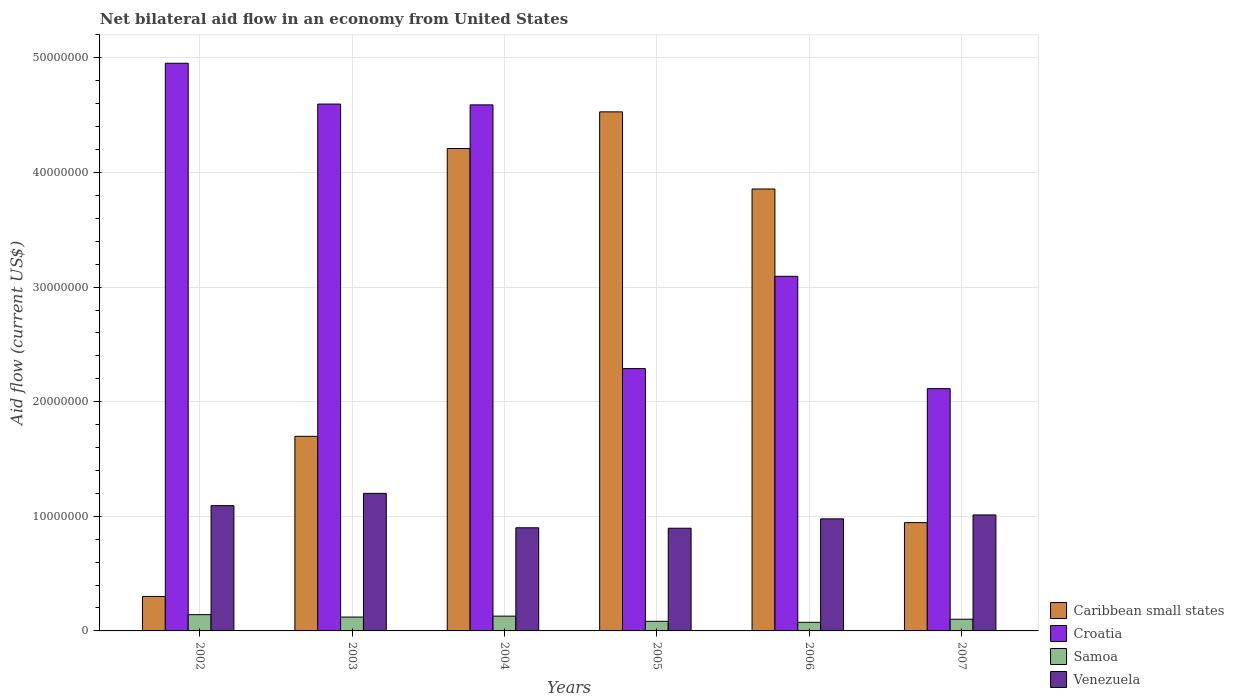How many bars are there on the 4th tick from the right?
Give a very brief answer. 4. What is the label of the 1st group of bars from the left?
Ensure brevity in your answer.  2002. What is the net bilateral aid flow in Venezuela in 2004?
Keep it short and to the point. 9.00e+06. Across all years, what is the maximum net bilateral aid flow in Samoa?
Offer a terse response. 1.42e+06. Across all years, what is the minimum net bilateral aid flow in Samoa?
Provide a succinct answer. 7.50e+05. In which year was the net bilateral aid flow in Caribbean small states minimum?
Make the answer very short. 2002. What is the total net bilateral aid flow in Croatia in the graph?
Your response must be concise. 2.16e+08. What is the difference between the net bilateral aid flow in Caribbean small states in 2002 and that in 2005?
Your answer should be very brief. -4.23e+07. What is the difference between the net bilateral aid flow in Venezuela in 2003 and the net bilateral aid flow in Croatia in 2004?
Your response must be concise. -3.39e+07. What is the average net bilateral aid flow in Venezuela per year?
Offer a terse response. 1.01e+07. In the year 2002, what is the difference between the net bilateral aid flow in Caribbean small states and net bilateral aid flow in Venezuela?
Offer a very short reply. -7.92e+06. In how many years, is the net bilateral aid flow in Venezuela greater than 48000000 US$?
Offer a very short reply. 0. What is the ratio of the net bilateral aid flow in Croatia in 2002 to that in 2005?
Offer a terse response. 2.16. What is the difference between the highest and the lowest net bilateral aid flow in Venezuela?
Your answer should be compact. 3.04e+06. In how many years, is the net bilateral aid flow in Venezuela greater than the average net bilateral aid flow in Venezuela taken over all years?
Your response must be concise. 2. Is the sum of the net bilateral aid flow in Samoa in 2004 and 2006 greater than the maximum net bilateral aid flow in Caribbean small states across all years?
Your answer should be compact. No. What does the 4th bar from the left in 2002 represents?
Your answer should be compact. Venezuela. What does the 4th bar from the right in 2007 represents?
Ensure brevity in your answer.  Caribbean small states. How many bars are there?
Your answer should be very brief. 24. How many years are there in the graph?
Your answer should be compact. 6. What is the difference between two consecutive major ticks on the Y-axis?
Your answer should be very brief. 1.00e+07. Where does the legend appear in the graph?
Make the answer very short. Bottom right. How many legend labels are there?
Keep it short and to the point. 4. How are the legend labels stacked?
Give a very brief answer. Vertical. What is the title of the graph?
Keep it short and to the point. Net bilateral aid flow in an economy from United States. Does "Bahrain" appear as one of the legend labels in the graph?
Ensure brevity in your answer.  No. What is the label or title of the X-axis?
Your response must be concise. Years. What is the label or title of the Y-axis?
Give a very brief answer. Aid flow (current US$). What is the Aid flow (current US$) in Caribbean small states in 2002?
Provide a succinct answer. 3.01e+06. What is the Aid flow (current US$) of Croatia in 2002?
Your answer should be compact. 4.95e+07. What is the Aid flow (current US$) of Samoa in 2002?
Your response must be concise. 1.42e+06. What is the Aid flow (current US$) of Venezuela in 2002?
Your response must be concise. 1.09e+07. What is the Aid flow (current US$) in Caribbean small states in 2003?
Provide a short and direct response. 1.70e+07. What is the Aid flow (current US$) in Croatia in 2003?
Your response must be concise. 4.60e+07. What is the Aid flow (current US$) in Samoa in 2003?
Offer a very short reply. 1.21e+06. What is the Aid flow (current US$) of Caribbean small states in 2004?
Provide a short and direct response. 4.21e+07. What is the Aid flow (current US$) of Croatia in 2004?
Your answer should be compact. 4.59e+07. What is the Aid flow (current US$) of Samoa in 2004?
Provide a short and direct response. 1.29e+06. What is the Aid flow (current US$) in Venezuela in 2004?
Your answer should be compact. 9.00e+06. What is the Aid flow (current US$) in Caribbean small states in 2005?
Give a very brief answer. 4.53e+07. What is the Aid flow (current US$) of Croatia in 2005?
Keep it short and to the point. 2.29e+07. What is the Aid flow (current US$) of Samoa in 2005?
Your response must be concise. 8.40e+05. What is the Aid flow (current US$) of Venezuela in 2005?
Provide a succinct answer. 8.96e+06. What is the Aid flow (current US$) of Caribbean small states in 2006?
Your answer should be compact. 3.86e+07. What is the Aid flow (current US$) of Croatia in 2006?
Provide a succinct answer. 3.09e+07. What is the Aid flow (current US$) of Samoa in 2006?
Provide a succinct answer. 7.50e+05. What is the Aid flow (current US$) in Venezuela in 2006?
Your response must be concise. 9.78e+06. What is the Aid flow (current US$) in Caribbean small states in 2007?
Offer a terse response. 9.45e+06. What is the Aid flow (current US$) in Croatia in 2007?
Make the answer very short. 2.11e+07. What is the Aid flow (current US$) of Samoa in 2007?
Your response must be concise. 1.02e+06. What is the Aid flow (current US$) in Venezuela in 2007?
Ensure brevity in your answer.  1.01e+07. Across all years, what is the maximum Aid flow (current US$) of Caribbean small states?
Offer a terse response. 4.53e+07. Across all years, what is the maximum Aid flow (current US$) of Croatia?
Your answer should be very brief. 4.95e+07. Across all years, what is the maximum Aid flow (current US$) of Samoa?
Provide a succinct answer. 1.42e+06. Across all years, what is the maximum Aid flow (current US$) of Venezuela?
Provide a short and direct response. 1.20e+07. Across all years, what is the minimum Aid flow (current US$) in Caribbean small states?
Provide a short and direct response. 3.01e+06. Across all years, what is the minimum Aid flow (current US$) of Croatia?
Offer a terse response. 2.11e+07. Across all years, what is the minimum Aid flow (current US$) in Samoa?
Your answer should be very brief. 7.50e+05. Across all years, what is the minimum Aid flow (current US$) in Venezuela?
Your answer should be compact. 8.96e+06. What is the total Aid flow (current US$) of Caribbean small states in the graph?
Give a very brief answer. 1.55e+08. What is the total Aid flow (current US$) of Croatia in the graph?
Ensure brevity in your answer.  2.16e+08. What is the total Aid flow (current US$) in Samoa in the graph?
Provide a short and direct response. 6.53e+06. What is the total Aid flow (current US$) in Venezuela in the graph?
Offer a terse response. 6.08e+07. What is the difference between the Aid flow (current US$) of Caribbean small states in 2002 and that in 2003?
Keep it short and to the point. -1.40e+07. What is the difference between the Aid flow (current US$) in Croatia in 2002 and that in 2003?
Offer a terse response. 3.56e+06. What is the difference between the Aid flow (current US$) in Venezuela in 2002 and that in 2003?
Give a very brief answer. -1.07e+06. What is the difference between the Aid flow (current US$) of Caribbean small states in 2002 and that in 2004?
Your answer should be very brief. -3.91e+07. What is the difference between the Aid flow (current US$) in Croatia in 2002 and that in 2004?
Your response must be concise. 3.63e+06. What is the difference between the Aid flow (current US$) of Venezuela in 2002 and that in 2004?
Your answer should be very brief. 1.93e+06. What is the difference between the Aid flow (current US$) in Caribbean small states in 2002 and that in 2005?
Give a very brief answer. -4.23e+07. What is the difference between the Aid flow (current US$) of Croatia in 2002 and that in 2005?
Provide a succinct answer. 2.66e+07. What is the difference between the Aid flow (current US$) in Samoa in 2002 and that in 2005?
Make the answer very short. 5.80e+05. What is the difference between the Aid flow (current US$) in Venezuela in 2002 and that in 2005?
Provide a short and direct response. 1.97e+06. What is the difference between the Aid flow (current US$) in Caribbean small states in 2002 and that in 2006?
Keep it short and to the point. -3.56e+07. What is the difference between the Aid flow (current US$) in Croatia in 2002 and that in 2006?
Give a very brief answer. 1.86e+07. What is the difference between the Aid flow (current US$) in Samoa in 2002 and that in 2006?
Ensure brevity in your answer.  6.70e+05. What is the difference between the Aid flow (current US$) in Venezuela in 2002 and that in 2006?
Keep it short and to the point. 1.15e+06. What is the difference between the Aid flow (current US$) of Caribbean small states in 2002 and that in 2007?
Make the answer very short. -6.44e+06. What is the difference between the Aid flow (current US$) in Croatia in 2002 and that in 2007?
Make the answer very short. 2.84e+07. What is the difference between the Aid flow (current US$) in Venezuela in 2002 and that in 2007?
Keep it short and to the point. 8.10e+05. What is the difference between the Aid flow (current US$) of Caribbean small states in 2003 and that in 2004?
Offer a very short reply. -2.51e+07. What is the difference between the Aid flow (current US$) of Samoa in 2003 and that in 2004?
Offer a terse response. -8.00e+04. What is the difference between the Aid flow (current US$) of Caribbean small states in 2003 and that in 2005?
Keep it short and to the point. -2.83e+07. What is the difference between the Aid flow (current US$) of Croatia in 2003 and that in 2005?
Your answer should be very brief. 2.31e+07. What is the difference between the Aid flow (current US$) in Venezuela in 2003 and that in 2005?
Offer a very short reply. 3.04e+06. What is the difference between the Aid flow (current US$) in Caribbean small states in 2003 and that in 2006?
Your response must be concise. -2.16e+07. What is the difference between the Aid flow (current US$) of Croatia in 2003 and that in 2006?
Keep it short and to the point. 1.50e+07. What is the difference between the Aid flow (current US$) of Samoa in 2003 and that in 2006?
Keep it short and to the point. 4.60e+05. What is the difference between the Aid flow (current US$) in Venezuela in 2003 and that in 2006?
Offer a terse response. 2.22e+06. What is the difference between the Aid flow (current US$) of Caribbean small states in 2003 and that in 2007?
Provide a succinct answer. 7.53e+06. What is the difference between the Aid flow (current US$) in Croatia in 2003 and that in 2007?
Your answer should be compact. 2.48e+07. What is the difference between the Aid flow (current US$) in Venezuela in 2003 and that in 2007?
Keep it short and to the point. 1.88e+06. What is the difference between the Aid flow (current US$) of Caribbean small states in 2004 and that in 2005?
Make the answer very short. -3.20e+06. What is the difference between the Aid flow (current US$) of Croatia in 2004 and that in 2005?
Provide a short and direct response. 2.30e+07. What is the difference between the Aid flow (current US$) in Caribbean small states in 2004 and that in 2006?
Offer a very short reply. 3.53e+06. What is the difference between the Aid flow (current US$) of Croatia in 2004 and that in 2006?
Offer a terse response. 1.50e+07. What is the difference between the Aid flow (current US$) of Samoa in 2004 and that in 2006?
Provide a short and direct response. 5.40e+05. What is the difference between the Aid flow (current US$) of Venezuela in 2004 and that in 2006?
Provide a succinct answer. -7.80e+05. What is the difference between the Aid flow (current US$) of Caribbean small states in 2004 and that in 2007?
Offer a terse response. 3.26e+07. What is the difference between the Aid flow (current US$) in Croatia in 2004 and that in 2007?
Your answer should be very brief. 2.48e+07. What is the difference between the Aid flow (current US$) in Venezuela in 2004 and that in 2007?
Give a very brief answer. -1.12e+06. What is the difference between the Aid flow (current US$) in Caribbean small states in 2005 and that in 2006?
Give a very brief answer. 6.73e+06. What is the difference between the Aid flow (current US$) in Croatia in 2005 and that in 2006?
Ensure brevity in your answer.  -8.05e+06. What is the difference between the Aid flow (current US$) in Venezuela in 2005 and that in 2006?
Your answer should be compact. -8.20e+05. What is the difference between the Aid flow (current US$) in Caribbean small states in 2005 and that in 2007?
Offer a very short reply. 3.58e+07. What is the difference between the Aid flow (current US$) in Croatia in 2005 and that in 2007?
Provide a succinct answer. 1.75e+06. What is the difference between the Aid flow (current US$) in Samoa in 2005 and that in 2007?
Provide a short and direct response. -1.80e+05. What is the difference between the Aid flow (current US$) of Venezuela in 2005 and that in 2007?
Offer a very short reply. -1.16e+06. What is the difference between the Aid flow (current US$) in Caribbean small states in 2006 and that in 2007?
Offer a very short reply. 2.91e+07. What is the difference between the Aid flow (current US$) in Croatia in 2006 and that in 2007?
Provide a short and direct response. 9.80e+06. What is the difference between the Aid flow (current US$) of Venezuela in 2006 and that in 2007?
Your answer should be very brief. -3.40e+05. What is the difference between the Aid flow (current US$) of Caribbean small states in 2002 and the Aid flow (current US$) of Croatia in 2003?
Provide a succinct answer. -4.30e+07. What is the difference between the Aid flow (current US$) in Caribbean small states in 2002 and the Aid flow (current US$) in Samoa in 2003?
Give a very brief answer. 1.80e+06. What is the difference between the Aid flow (current US$) of Caribbean small states in 2002 and the Aid flow (current US$) of Venezuela in 2003?
Provide a succinct answer. -8.99e+06. What is the difference between the Aid flow (current US$) of Croatia in 2002 and the Aid flow (current US$) of Samoa in 2003?
Keep it short and to the point. 4.83e+07. What is the difference between the Aid flow (current US$) of Croatia in 2002 and the Aid flow (current US$) of Venezuela in 2003?
Your response must be concise. 3.75e+07. What is the difference between the Aid flow (current US$) of Samoa in 2002 and the Aid flow (current US$) of Venezuela in 2003?
Your answer should be compact. -1.06e+07. What is the difference between the Aid flow (current US$) of Caribbean small states in 2002 and the Aid flow (current US$) of Croatia in 2004?
Your response must be concise. -4.29e+07. What is the difference between the Aid flow (current US$) of Caribbean small states in 2002 and the Aid flow (current US$) of Samoa in 2004?
Offer a terse response. 1.72e+06. What is the difference between the Aid flow (current US$) of Caribbean small states in 2002 and the Aid flow (current US$) of Venezuela in 2004?
Your answer should be compact. -5.99e+06. What is the difference between the Aid flow (current US$) of Croatia in 2002 and the Aid flow (current US$) of Samoa in 2004?
Offer a terse response. 4.82e+07. What is the difference between the Aid flow (current US$) in Croatia in 2002 and the Aid flow (current US$) in Venezuela in 2004?
Offer a very short reply. 4.05e+07. What is the difference between the Aid flow (current US$) of Samoa in 2002 and the Aid flow (current US$) of Venezuela in 2004?
Provide a short and direct response. -7.58e+06. What is the difference between the Aid flow (current US$) in Caribbean small states in 2002 and the Aid flow (current US$) in Croatia in 2005?
Provide a succinct answer. -1.99e+07. What is the difference between the Aid flow (current US$) of Caribbean small states in 2002 and the Aid flow (current US$) of Samoa in 2005?
Ensure brevity in your answer.  2.17e+06. What is the difference between the Aid flow (current US$) of Caribbean small states in 2002 and the Aid flow (current US$) of Venezuela in 2005?
Your answer should be very brief. -5.95e+06. What is the difference between the Aid flow (current US$) in Croatia in 2002 and the Aid flow (current US$) in Samoa in 2005?
Provide a succinct answer. 4.87e+07. What is the difference between the Aid flow (current US$) of Croatia in 2002 and the Aid flow (current US$) of Venezuela in 2005?
Ensure brevity in your answer.  4.06e+07. What is the difference between the Aid flow (current US$) of Samoa in 2002 and the Aid flow (current US$) of Venezuela in 2005?
Offer a terse response. -7.54e+06. What is the difference between the Aid flow (current US$) of Caribbean small states in 2002 and the Aid flow (current US$) of Croatia in 2006?
Your response must be concise. -2.79e+07. What is the difference between the Aid flow (current US$) in Caribbean small states in 2002 and the Aid flow (current US$) in Samoa in 2006?
Ensure brevity in your answer.  2.26e+06. What is the difference between the Aid flow (current US$) of Caribbean small states in 2002 and the Aid flow (current US$) of Venezuela in 2006?
Ensure brevity in your answer.  -6.77e+06. What is the difference between the Aid flow (current US$) of Croatia in 2002 and the Aid flow (current US$) of Samoa in 2006?
Offer a terse response. 4.88e+07. What is the difference between the Aid flow (current US$) of Croatia in 2002 and the Aid flow (current US$) of Venezuela in 2006?
Give a very brief answer. 3.98e+07. What is the difference between the Aid flow (current US$) of Samoa in 2002 and the Aid flow (current US$) of Venezuela in 2006?
Your response must be concise. -8.36e+06. What is the difference between the Aid flow (current US$) of Caribbean small states in 2002 and the Aid flow (current US$) of Croatia in 2007?
Provide a short and direct response. -1.81e+07. What is the difference between the Aid flow (current US$) in Caribbean small states in 2002 and the Aid flow (current US$) in Samoa in 2007?
Provide a succinct answer. 1.99e+06. What is the difference between the Aid flow (current US$) in Caribbean small states in 2002 and the Aid flow (current US$) in Venezuela in 2007?
Offer a very short reply. -7.11e+06. What is the difference between the Aid flow (current US$) of Croatia in 2002 and the Aid flow (current US$) of Samoa in 2007?
Your answer should be very brief. 4.85e+07. What is the difference between the Aid flow (current US$) of Croatia in 2002 and the Aid flow (current US$) of Venezuela in 2007?
Offer a terse response. 3.94e+07. What is the difference between the Aid flow (current US$) in Samoa in 2002 and the Aid flow (current US$) in Venezuela in 2007?
Provide a short and direct response. -8.70e+06. What is the difference between the Aid flow (current US$) in Caribbean small states in 2003 and the Aid flow (current US$) in Croatia in 2004?
Your answer should be compact. -2.89e+07. What is the difference between the Aid flow (current US$) of Caribbean small states in 2003 and the Aid flow (current US$) of Samoa in 2004?
Ensure brevity in your answer.  1.57e+07. What is the difference between the Aid flow (current US$) in Caribbean small states in 2003 and the Aid flow (current US$) in Venezuela in 2004?
Your answer should be very brief. 7.98e+06. What is the difference between the Aid flow (current US$) in Croatia in 2003 and the Aid flow (current US$) in Samoa in 2004?
Provide a short and direct response. 4.47e+07. What is the difference between the Aid flow (current US$) in Croatia in 2003 and the Aid flow (current US$) in Venezuela in 2004?
Your response must be concise. 3.70e+07. What is the difference between the Aid flow (current US$) in Samoa in 2003 and the Aid flow (current US$) in Venezuela in 2004?
Offer a terse response. -7.79e+06. What is the difference between the Aid flow (current US$) in Caribbean small states in 2003 and the Aid flow (current US$) in Croatia in 2005?
Provide a succinct answer. -5.91e+06. What is the difference between the Aid flow (current US$) of Caribbean small states in 2003 and the Aid flow (current US$) of Samoa in 2005?
Your answer should be very brief. 1.61e+07. What is the difference between the Aid flow (current US$) in Caribbean small states in 2003 and the Aid flow (current US$) in Venezuela in 2005?
Ensure brevity in your answer.  8.02e+06. What is the difference between the Aid flow (current US$) of Croatia in 2003 and the Aid flow (current US$) of Samoa in 2005?
Your response must be concise. 4.51e+07. What is the difference between the Aid flow (current US$) of Croatia in 2003 and the Aid flow (current US$) of Venezuela in 2005?
Your response must be concise. 3.70e+07. What is the difference between the Aid flow (current US$) in Samoa in 2003 and the Aid flow (current US$) in Venezuela in 2005?
Provide a short and direct response. -7.75e+06. What is the difference between the Aid flow (current US$) in Caribbean small states in 2003 and the Aid flow (current US$) in Croatia in 2006?
Your answer should be compact. -1.40e+07. What is the difference between the Aid flow (current US$) of Caribbean small states in 2003 and the Aid flow (current US$) of Samoa in 2006?
Keep it short and to the point. 1.62e+07. What is the difference between the Aid flow (current US$) of Caribbean small states in 2003 and the Aid flow (current US$) of Venezuela in 2006?
Your answer should be very brief. 7.20e+06. What is the difference between the Aid flow (current US$) in Croatia in 2003 and the Aid flow (current US$) in Samoa in 2006?
Offer a terse response. 4.52e+07. What is the difference between the Aid flow (current US$) of Croatia in 2003 and the Aid flow (current US$) of Venezuela in 2006?
Your answer should be very brief. 3.62e+07. What is the difference between the Aid flow (current US$) in Samoa in 2003 and the Aid flow (current US$) in Venezuela in 2006?
Provide a succinct answer. -8.57e+06. What is the difference between the Aid flow (current US$) of Caribbean small states in 2003 and the Aid flow (current US$) of Croatia in 2007?
Your answer should be compact. -4.16e+06. What is the difference between the Aid flow (current US$) of Caribbean small states in 2003 and the Aid flow (current US$) of Samoa in 2007?
Provide a short and direct response. 1.60e+07. What is the difference between the Aid flow (current US$) of Caribbean small states in 2003 and the Aid flow (current US$) of Venezuela in 2007?
Offer a very short reply. 6.86e+06. What is the difference between the Aid flow (current US$) of Croatia in 2003 and the Aid flow (current US$) of Samoa in 2007?
Make the answer very short. 4.50e+07. What is the difference between the Aid flow (current US$) of Croatia in 2003 and the Aid flow (current US$) of Venezuela in 2007?
Keep it short and to the point. 3.58e+07. What is the difference between the Aid flow (current US$) of Samoa in 2003 and the Aid flow (current US$) of Venezuela in 2007?
Provide a succinct answer. -8.91e+06. What is the difference between the Aid flow (current US$) of Caribbean small states in 2004 and the Aid flow (current US$) of Croatia in 2005?
Your answer should be compact. 1.92e+07. What is the difference between the Aid flow (current US$) of Caribbean small states in 2004 and the Aid flow (current US$) of Samoa in 2005?
Keep it short and to the point. 4.12e+07. What is the difference between the Aid flow (current US$) of Caribbean small states in 2004 and the Aid flow (current US$) of Venezuela in 2005?
Offer a very short reply. 3.31e+07. What is the difference between the Aid flow (current US$) of Croatia in 2004 and the Aid flow (current US$) of Samoa in 2005?
Your answer should be compact. 4.51e+07. What is the difference between the Aid flow (current US$) of Croatia in 2004 and the Aid flow (current US$) of Venezuela in 2005?
Your answer should be compact. 3.69e+07. What is the difference between the Aid flow (current US$) in Samoa in 2004 and the Aid flow (current US$) in Venezuela in 2005?
Your answer should be very brief. -7.67e+06. What is the difference between the Aid flow (current US$) in Caribbean small states in 2004 and the Aid flow (current US$) in Croatia in 2006?
Provide a short and direct response. 1.12e+07. What is the difference between the Aid flow (current US$) in Caribbean small states in 2004 and the Aid flow (current US$) in Samoa in 2006?
Provide a succinct answer. 4.13e+07. What is the difference between the Aid flow (current US$) of Caribbean small states in 2004 and the Aid flow (current US$) of Venezuela in 2006?
Your answer should be very brief. 3.23e+07. What is the difference between the Aid flow (current US$) of Croatia in 2004 and the Aid flow (current US$) of Samoa in 2006?
Offer a very short reply. 4.52e+07. What is the difference between the Aid flow (current US$) in Croatia in 2004 and the Aid flow (current US$) in Venezuela in 2006?
Your answer should be compact. 3.61e+07. What is the difference between the Aid flow (current US$) in Samoa in 2004 and the Aid flow (current US$) in Venezuela in 2006?
Ensure brevity in your answer.  -8.49e+06. What is the difference between the Aid flow (current US$) in Caribbean small states in 2004 and the Aid flow (current US$) in Croatia in 2007?
Offer a terse response. 2.10e+07. What is the difference between the Aid flow (current US$) in Caribbean small states in 2004 and the Aid flow (current US$) in Samoa in 2007?
Ensure brevity in your answer.  4.11e+07. What is the difference between the Aid flow (current US$) in Caribbean small states in 2004 and the Aid flow (current US$) in Venezuela in 2007?
Provide a short and direct response. 3.20e+07. What is the difference between the Aid flow (current US$) of Croatia in 2004 and the Aid flow (current US$) of Samoa in 2007?
Keep it short and to the point. 4.49e+07. What is the difference between the Aid flow (current US$) of Croatia in 2004 and the Aid flow (current US$) of Venezuela in 2007?
Offer a terse response. 3.58e+07. What is the difference between the Aid flow (current US$) of Samoa in 2004 and the Aid flow (current US$) of Venezuela in 2007?
Your answer should be very brief. -8.83e+06. What is the difference between the Aid flow (current US$) in Caribbean small states in 2005 and the Aid flow (current US$) in Croatia in 2006?
Provide a short and direct response. 1.44e+07. What is the difference between the Aid flow (current US$) in Caribbean small states in 2005 and the Aid flow (current US$) in Samoa in 2006?
Provide a succinct answer. 4.45e+07. What is the difference between the Aid flow (current US$) of Caribbean small states in 2005 and the Aid flow (current US$) of Venezuela in 2006?
Give a very brief answer. 3.55e+07. What is the difference between the Aid flow (current US$) in Croatia in 2005 and the Aid flow (current US$) in Samoa in 2006?
Offer a terse response. 2.21e+07. What is the difference between the Aid flow (current US$) of Croatia in 2005 and the Aid flow (current US$) of Venezuela in 2006?
Provide a short and direct response. 1.31e+07. What is the difference between the Aid flow (current US$) in Samoa in 2005 and the Aid flow (current US$) in Venezuela in 2006?
Offer a terse response. -8.94e+06. What is the difference between the Aid flow (current US$) of Caribbean small states in 2005 and the Aid flow (current US$) of Croatia in 2007?
Provide a short and direct response. 2.42e+07. What is the difference between the Aid flow (current US$) of Caribbean small states in 2005 and the Aid flow (current US$) of Samoa in 2007?
Provide a succinct answer. 4.43e+07. What is the difference between the Aid flow (current US$) in Caribbean small states in 2005 and the Aid flow (current US$) in Venezuela in 2007?
Your answer should be compact. 3.52e+07. What is the difference between the Aid flow (current US$) of Croatia in 2005 and the Aid flow (current US$) of Samoa in 2007?
Keep it short and to the point. 2.19e+07. What is the difference between the Aid flow (current US$) of Croatia in 2005 and the Aid flow (current US$) of Venezuela in 2007?
Your response must be concise. 1.28e+07. What is the difference between the Aid flow (current US$) of Samoa in 2005 and the Aid flow (current US$) of Venezuela in 2007?
Provide a short and direct response. -9.28e+06. What is the difference between the Aid flow (current US$) of Caribbean small states in 2006 and the Aid flow (current US$) of Croatia in 2007?
Your answer should be compact. 1.74e+07. What is the difference between the Aid flow (current US$) of Caribbean small states in 2006 and the Aid flow (current US$) of Samoa in 2007?
Keep it short and to the point. 3.75e+07. What is the difference between the Aid flow (current US$) of Caribbean small states in 2006 and the Aid flow (current US$) of Venezuela in 2007?
Provide a succinct answer. 2.84e+07. What is the difference between the Aid flow (current US$) of Croatia in 2006 and the Aid flow (current US$) of Samoa in 2007?
Give a very brief answer. 2.99e+07. What is the difference between the Aid flow (current US$) of Croatia in 2006 and the Aid flow (current US$) of Venezuela in 2007?
Make the answer very short. 2.08e+07. What is the difference between the Aid flow (current US$) of Samoa in 2006 and the Aid flow (current US$) of Venezuela in 2007?
Keep it short and to the point. -9.37e+06. What is the average Aid flow (current US$) of Caribbean small states per year?
Ensure brevity in your answer.  2.59e+07. What is the average Aid flow (current US$) of Croatia per year?
Your response must be concise. 3.61e+07. What is the average Aid flow (current US$) of Samoa per year?
Offer a terse response. 1.09e+06. What is the average Aid flow (current US$) of Venezuela per year?
Ensure brevity in your answer.  1.01e+07. In the year 2002, what is the difference between the Aid flow (current US$) in Caribbean small states and Aid flow (current US$) in Croatia?
Offer a very short reply. -4.65e+07. In the year 2002, what is the difference between the Aid flow (current US$) in Caribbean small states and Aid flow (current US$) in Samoa?
Provide a short and direct response. 1.59e+06. In the year 2002, what is the difference between the Aid flow (current US$) in Caribbean small states and Aid flow (current US$) in Venezuela?
Provide a short and direct response. -7.92e+06. In the year 2002, what is the difference between the Aid flow (current US$) of Croatia and Aid flow (current US$) of Samoa?
Your answer should be very brief. 4.81e+07. In the year 2002, what is the difference between the Aid flow (current US$) of Croatia and Aid flow (current US$) of Venezuela?
Ensure brevity in your answer.  3.86e+07. In the year 2002, what is the difference between the Aid flow (current US$) in Samoa and Aid flow (current US$) in Venezuela?
Give a very brief answer. -9.51e+06. In the year 2003, what is the difference between the Aid flow (current US$) in Caribbean small states and Aid flow (current US$) in Croatia?
Provide a succinct answer. -2.90e+07. In the year 2003, what is the difference between the Aid flow (current US$) of Caribbean small states and Aid flow (current US$) of Samoa?
Offer a very short reply. 1.58e+07. In the year 2003, what is the difference between the Aid flow (current US$) of Caribbean small states and Aid flow (current US$) of Venezuela?
Keep it short and to the point. 4.98e+06. In the year 2003, what is the difference between the Aid flow (current US$) in Croatia and Aid flow (current US$) in Samoa?
Your response must be concise. 4.48e+07. In the year 2003, what is the difference between the Aid flow (current US$) of Croatia and Aid flow (current US$) of Venezuela?
Your answer should be compact. 3.40e+07. In the year 2003, what is the difference between the Aid flow (current US$) in Samoa and Aid flow (current US$) in Venezuela?
Keep it short and to the point. -1.08e+07. In the year 2004, what is the difference between the Aid flow (current US$) in Caribbean small states and Aid flow (current US$) in Croatia?
Ensure brevity in your answer.  -3.81e+06. In the year 2004, what is the difference between the Aid flow (current US$) in Caribbean small states and Aid flow (current US$) in Samoa?
Offer a very short reply. 4.08e+07. In the year 2004, what is the difference between the Aid flow (current US$) in Caribbean small states and Aid flow (current US$) in Venezuela?
Offer a terse response. 3.31e+07. In the year 2004, what is the difference between the Aid flow (current US$) of Croatia and Aid flow (current US$) of Samoa?
Your answer should be very brief. 4.46e+07. In the year 2004, what is the difference between the Aid flow (current US$) of Croatia and Aid flow (current US$) of Venezuela?
Provide a short and direct response. 3.69e+07. In the year 2004, what is the difference between the Aid flow (current US$) of Samoa and Aid flow (current US$) of Venezuela?
Provide a short and direct response. -7.71e+06. In the year 2005, what is the difference between the Aid flow (current US$) of Caribbean small states and Aid flow (current US$) of Croatia?
Keep it short and to the point. 2.24e+07. In the year 2005, what is the difference between the Aid flow (current US$) in Caribbean small states and Aid flow (current US$) in Samoa?
Offer a terse response. 4.44e+07. In the year 2005, what is the difference between the Aid flow (current US$) of Caribbean small states and Aid flow (current US$) of Venezuela?
Give a very brief answer. 3.63e+07. In the year 2005, what is the difference between the Aid flow (current US$) in Croatia and Aid flow (current US$) in Samoa?
Keep it short and to the point. 2.20e+07. In the year 2005, what is the difference between the Aid flow (current US$) of Croatia and Aid flow (current US$) of Venezuela?
Your answer should be compact. 1.39e+07. In the year 2005, what is the difference between the Aid flow (current US$) in Samoa and Aid flow (current US$) in Venezuela?
Your response must be concise. -8.12e+06. In the year 2006, what is the difference between the Aid flow (current US$) of Caribbean small states and Aid flow (current US$) of Croatia?
Offer a terse response. 7.62e+06. In the year 2006, what is the difference between the Aid flow (current US$) of Caribbean small states and Aid flow (current US$) of Samoa?
Your answer should be very brief. 3.78e+07. In the year 2006, what is the difference between the Aid flow (current US$) of Caribbean small states and Aid flow (current US$) of Venezuela?
Make the answer very short. 2.88e+07. In the year 2006, what is the difference between the Aid flow (current US$) of Croatia and Aid flow (current US$) of Samoa?
Your answer should be compact. 3.02e+07. In the year 2006, what is the difference between the Aid flow (current US$) in Croatia and Aid flow (current US$) in Venezuela?
Offer a very short reply. 2.12e+07. In the year 2006, what is the difference between the Aid flow (current US$) of Samoa and Aid flow (current US$) of Venezuela?
Offer a terse response. -9.03e+06. In the year 2007, what is the difference between the Aid flow (current US$) of Caribbean small states and Aid flow (current US$) of Croatia?
Give a very brief answer. -1.17e+07. In the year 2007, what is the difference between the Aid flow (current US$) of Caribbean small states and Aid flow (current US$) of Samoa?
Provide a short and direct response. 8.43e+06. In the year 2007, what is the difference between the Aid flow (current US$) of Caribbean small states and Aid flow (current US$) of Venezuela?
Your answer should be compact. -6.70e+05. In the year 2007, what is the difference between the Aid flow (current US$) in Croatia and Aid flow (current US$) in Samoa?
Give a very brief answer. 2.01e+07. In the year 2007, what is the difference between the Aid flow (current US$) of Croatia and Aid flow (current US$) of Venezuela?
Keep it short and to the point. 1.10e+07. In the year 2007, what is the difference between the Aid flow (current US$) of Samoa and Aid flow (current US$) of Venezuela?
Provide a succinct answer. -9.10e+06. What is the ratio of the Aid flow (current US$) of Caribbean small states in 2002 to that in 2003?
Your answer should be compact. 0.18. What is the ratio of the Aid flow (current US$) in Croatia in 2002 to that in 2003?
Your answer should be very brief. 1.08. What is the ratio of the Aid flow (current US$) of Samoa in 2002 to that in 2003?
Your response must be concise. 1.17. What is the ratio of the Aid flow (current US$) of Venezuela in 2002 to that in 2003?
Ensure brevity in your answer.  0.91. What is the ratio of the Aid flow (current US$) in Caribbean small states in 2002 to that in 2004?
Give a very brief answer. 0.07. What is the ratio of the Aid flow (current US$) of Croatia in 2002 to that in 2004?
Offer a very short reply. 1.08. What is the ratio of the Aid flow (current US$) in Samoa in 2002 to that in 2004?
Your answer should be very brief. 1.1. What is the ratio of the Aid flow (current US$) in Venezuela in 2002 to that in 2004?
Give a very brief answer. 1.21. What is the ratio of the Aid flow (current US$) in Caribbean small states in 2002 to that in 2005?
Make the answer very short. 0.07. What is the ratio of the Aid flow (current US$) of Croatia in 2002 to that in 2005?
Provide a succinct answer. 2.16. What is the ratio of the Aid flow (current US$) of Samoa in 2002 to that in 2005?
Offer a terse response. 1.69. What is the ratio of the Aid flow (current US$) in Venezuela in 2002 to that in 2005?
Your response must be concise. 1.22. What is the ratio of the Aid flow (current US$) in Caribbean small states in 2002 to that in 2006?
Make the answer very short. 0.08. What is the ratio of the Aid flow (current US$) in Croatia in 2002 to that in 2006?
Your answer should be very brief. 1.6. What is the ratio of the Aid flow (current US$) of Samoa in 2002 to that in 2006?
Offer a very short reply. 1.89. What is the ratio of the Aid flow (current US$) of Venezuela in 2002 to that in 2006?
Provide a short and direct response. 1.12. What is the ratio of the Aid flow (current US$) in Caribbean small states in 2002 to that in 2007?
Offer a very short reply. 0.32. What is the ratio of the Aid flow (current US$) of Croatia in 2002 to that in 2007?
Make the answer very short. 2.34. What is the ratio of the Aid flow (current US$) in Samoa in 2002 to that in 2007?
Your answer should be very brief. 1.39. What is the ratio of the Aid flow (current US$) in Venezuela in 2002 to that in 2007?
Your answer should be very brief. 1.08. What is the ratio of the Aid flow (current US$) of Caribbean small states in 2003 to that in 2004?
Ensure brevity in your answer.  0.4. What is the ratio of the Aid flow (current US$) of Samoa in 2003 to that in 2004?
Offer a terse response. 0.94. What is the ratio of the Aid flow (current US$) in Caribbean small states in 2003 to that in 2005?
Make the answer very short. 0.37. What is the ratio of the Aid flow (current US$) of Croatia in 2003 to that in 2005?
Keep it short and to the point. 2.01. What is the ratio of the Aid flow (current US$) of Samoa in 2003 to that in 2005?
Give a very brief answer. 1.44. What is the ratio of the Aid flow (current US$) in Venezuela in 2003 to that in 2005?
Ensure brevity in your answer.  1.34. What is the ratio of the Aid flow (current US$) of Caribbean small states in 2003 to that in 2006?
Make the answer very short. 0.44. What is the ratio of the Aid flow (current US$) of Croatia in 2003 to that in 2006?
Give a very brief answer. 1.49. What is the ratio of the Aid flow (current US$) in Samoa in 2003 to that in 2006?
Offer a very short reply. 1.61. What is the ratio of the Aid flow (current US$) of Venezuela in 2003 to that in 2006?
Keep it short and to the point. 1.23. What is the ratio of the Aid flow (current US$) of Caribbean small states in 2003 to that in 2007?
Ensure brevity in your answer.  1.8. What is the ratio of the Aid flow (current US$) of Croatia in 2003 to that in 2007?
Provide a succinct answer. 2.17. What is the ratio of the Aid flow (current US$) of Samoa in 2003 to that in 2007?
Provide a short and direct response. 1.19. What is the ratio of the Aid flow (current US$) in Venezuela in 2003 to that in 2007?
Provide a short and direct response. 1.19. What is the ratio of the Aid flow (current US$) in Caribbean small states in 2004 to that in 2005?
Provide a short and direct response. 0.93. What is the ratio of the Aid flow (current US$) in Croatia in 2004 to that in 2005?
Offer a very short reply. 2.01. What is the ratio of the Aid flow (current US$) in Samoa in 2004 to that in 2005?
Offer a terse response. 1.54. What is the ratio of the Aid flow (current US$) in Caribbean small states in 2004 to that in 2006?
Offer a terse response. 1.09. What is the ratio of the Aid flow (current US$) of Croatia in 2004 to that in 2006?
Your answer should be very brief. 1.48. What is the ratio of the Aid flow (current US$) in Samoa in 2004 to that in 2006?
Give a very brief answer. 1.72. What is the ratio of the Aid flow (current US$) of Venezuela in 2004 to that in 2006?
Your answer should be compact. 0.92. What is the ratio of the Aid flow (current US$) in Caribbean small states in 2004 to that in 2007?
Offer a very short reply. 4.45. What is the ratio of the Aid flow (current US$) of Croatia in 2004 to that in 2007?
Make the answer very short. 2.17. What is the ratio of the Aid flow (current US$) of Samoa in 2004 to that in 2007?
Offer a terse response. 1.26. What is the ratio of the Aid flow (current US$) in Venezuela in 2004 to that in 2007?
Give a very brief answer. 0.89. What is the ratio of the Aid flow (current US$) in Caribbean small states in 2005 to that in 2006?
Give a very brief answer. 1.17. What is the ratio of the Aid flow (current US$) in Croatia in 2005 to that in 2006?
Offer a terse response. 0.74. What is the ratio of the Aid flow (current US$) in Samoa in 2005 to that in 2006?
Your answer should be compact. 1.12. What is the ratio of the Aid flow (current US$) in Venezuela in 2005 to that in 2006?
Provide a succinct answer. 0.92. What is the ratio of the Aid flow (current US$) of Caribbean small states in 2005 to that in 2007?
Keep it short and to the point. 4.79. What is the ratio of the Aid flow (current US$) of Croatia in 2005 to that in 2007?
Make the answer very short. 1.08. What is the ratio of the Aid flow (current US$) in Samoa in 2005 to that in 2007?
Give a very brief answer. 0.82. What is the ratio of the Aid flow (current US$) in Venezuela in 2005 to that in 2007?
Ensure brevity in your answer.  0.89. What is the ratio of the Aid flow (current US$) in Caribbean small states in 2006 to that in 2007?
Make the answer very short. 4.08. What is the ratio of the Aid flow (current US$) of Croatia in 2006 to that in 2007?
Ensure brevity in your answer.  1.46. What is the ratio of the Aid flow (current US$) of Samoa in 2006 to that in 2007?
Ensure brevity in your answer.  0.74. What is the ratio of the Aid flow (current US$) in Venezuela in 2006 to that in 2007?
Give a very brief answer. 0.97. What is the difference between the highest and the second highest Aid flow (current US$) of Caribbean small states?
Your answer should be very brief. 3.20e+06. What is the difference between the highest and the second highest Aid flow (current US$) of Croatia?
Your answer should be very brief. 3.56e+06. What is the difference between the highest and the second highest Aid flow (current US$) in Venezuela?
Offer a terse response. 1.07e+06. What is the difference between the highest and the lowest Aid flow (current US$) in Caribbean small states?
Make the answer very short. 4.23e+07. What is the difference between the highest and the lowest Aid flow (current US$) in Croatia?
Provide a succinct answer. 2.84e+07. What is the difference between the highest and the lowest Aid flow (current US$) in Samoa?
Your answer should be very brief. 6.70e+05. What is the difference between the highest and the lowest Aid flow (current US$) of Venezuela?
Make the answer very short. 3.04e+06. 